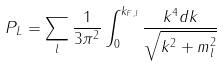<formula> <loc_0><loc_0><loc_500><loc_500>P _ { L } = \sum _ { l } \frac { 1 } { 3 \pi ^ { 2 } } \int _ { 0 } ^ { k _ { F , l } } \frac { k ^ { 4 } d k } { \sqrt { k ^ { 2 } + m _ { l } ^ { 2 } } }</formula> 